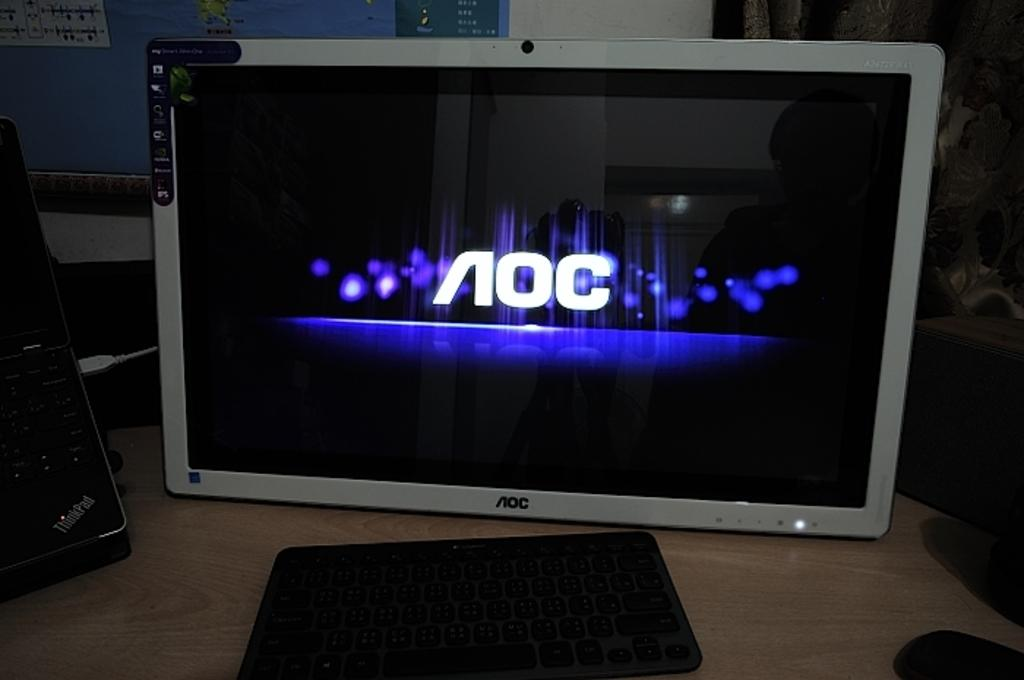Provide a one-sentence caption for the provided image. An AOC computer monitor is illuminated on a desktop. 